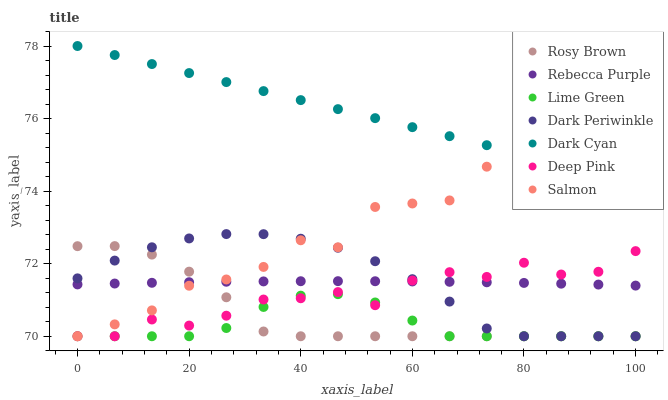Does Lime Green have the minimum area under the curve?
Answer yes or no. Yes. Does Dark Cyan have the maximum area under the curve?
Answer yes or no. Yes. Does Rosy Brown have the minimum area under the curve?
Answer yes or no. No. Does Rosy Brown have the maximum area under the curve?
Answer yes or no. No. Is Dark Cyan the smoothest?
Answer yes or no. Yes. Is Salmon the roughest?
Answer yes or no. Yes. Is Rosy Brown the smoothest?
Answer yes or no. No. Is Rosy Brown the roughest?
Answer yes or no. No. Does Deep Pink have the lowest value?
Answer yes or no. Yes. Does Rebecca Purple have the lowest value?
Answer yes or no. No. Does Dark Cyan have the highest value?
Answer yes or no. Yes. Does Rosy Brown have the highest value?
Answer yes or no. No. Is Rebecca Purple less than Dark Cyan?
Answer yes or no. Yes. Is Dark Cyan greater than Lime Green?
Answer yes or no. Yes. Does Deep Pink intersect Lime Green?
Answer yes or no. Yes. Is Deep Pink less than Lime Green?
Answer yes or no. No. Is Deep Pink greater than Lime Green?
Answer yes or no. No. Does Rebecca Purple intersect Dark Cyan?
Answer yes or no. No. 